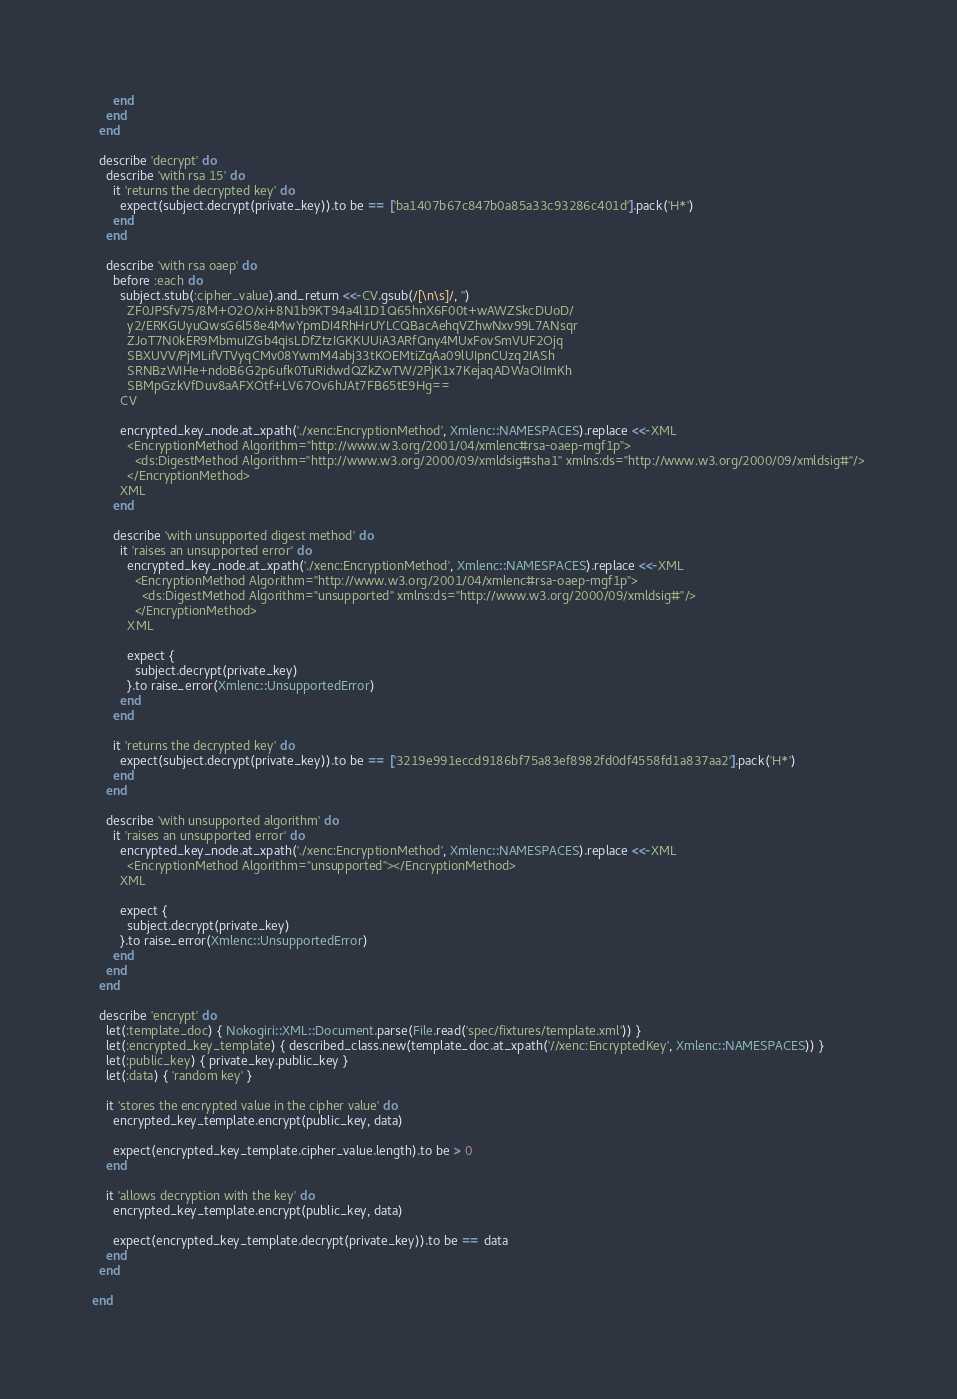<code> <loc_0><loc_0><loc_500><loc_500><_Ruby_>      end
    end
  end

  describe 'decrypt' do
    describe 'with rsa 15' do
      it 'returns the decrypted key' do
        expect(subject.decrypt(private_key)).to be == ['ba1407b67c847b0a85a33c93286c401d'].pack('H*')
      end
    end

    describe 'with rsa oaep' do
      before :each do
        subject.stub(:cipher_value).and_return <<-CV.gsub(/[\n\s]/, '')
          ZF0JPSfv75/8M+O2O/xi+8N1b9KT94a4l1D1Q65hnX6F00t+wAWZSkcDUoD/
          y2/ERKGUyuQwsG6l58e4MwYpmDI4RhHrUYLCQBacAehqVZhwNxv99L7ANsqr
          ZJoT7N0kER9MbmuIZGb4qisLDfZtzIGKKUUiA3ARfQny4MUxFovSmVUF2Ojq
          SBXUVV/PjMLifVTVyqCMv08YwmM4abj33tKOEMtiZqAa09lUIpnCUzq2IASh
          SRNBzWIHe+ndoB6G2p6ufk0TuRidwdQZkZwTW/2PjK1x7KejaqADWaOIImKh
          SBMpGzkVfDuv8aAFXOtf+LV67Ov6hJAt7FB65tE9Hg==
        CV

        encrypted_key_node.at_xpath('./xenc:EncryptionMethod', Xmlenc::NAMESPACES).replace <<-XML
          <EncryptionMethod Algorithm="http://www.w3.org/2001/04/xmlenc#rsa-oaep-mgf1p">
            <ds:DigestMethod Algorithm="http://www.w3.org/2000/09/xmldsig#sha1" xmlns:ds="http://www.w3.org/2000/09/xmldsig#"/>
          </EncryptionMethod>
        XML
      end

      describe 'with unsupported digest method' do
        it 'raises an unsupported error' do
          encrypted_key_node.at_xpath('./xenc:EncryptionMethod', Xmlenc::NAMESPACES).replace <<-XML
            <EncryptionMethod Algorithm="http://www.w3.org/2001/04/xmlenc#rsa-oaep-mgf1p">
              <ds:DigestMethod Algorithm="unsupported" xmlns:ds="http://www.w3.org/2000/09/xmldsig#"/>
            </EncryptionMethod>
          XML

          expect {
            subject.decrypt(private_key)
          }.to raise_error(Xmlenc::UnsupportedError)
        end
      end

      it 'returns the decrypted key' do
        expect(subject.decrypt(private_key)).to be == ['3219e991eccd9186bf75a83ef8982fd0df4558fd1a837aa2'].pack('H*')
      end
    end

    describe 'with unsupported algorithm' do
      it 'raises an unsupported error' do
        encrypted_key_node.at_xpath('./xenc:EncryptionMethod', Xmlenc::NAMESPACES).replace <<-XML
          <EncryptionMethod Algorithm="unsupported"></EncryptionMethod>
        XML

        expect {
          subject.decrypt(private_key)
        }.to raise_error(Xmlenc::UnsupportedError)
      end
    end
  end

  describe 'encrypt' do
    let(:template_doc) { Nokogiri::XML::Document.parse(File.read('spec/fixtures/template.xml')) }
    let(:encrypted_key_template) { described_class.new(template_doc.at_xpath('//xenc:EncryptedKey', Xmlenc::NAMESPACES)) }
    let(:public_key) { private_key.public_key }
    let(:data) { 'random key' }

    it 'stores the encrypted value in the cipher value' do
      encrypted_key_template.encrypt(public_key, data)

      expect(encrypted_key_template.cipher_value.length).to be > 0
    end

    it 'allows decryption with the key' do
      encrypted_key_template.encrypt(public_key, data)

      expect(encrypted_key_template.decrypt(private_key)).to be == data
    end
  end

end
</code> 